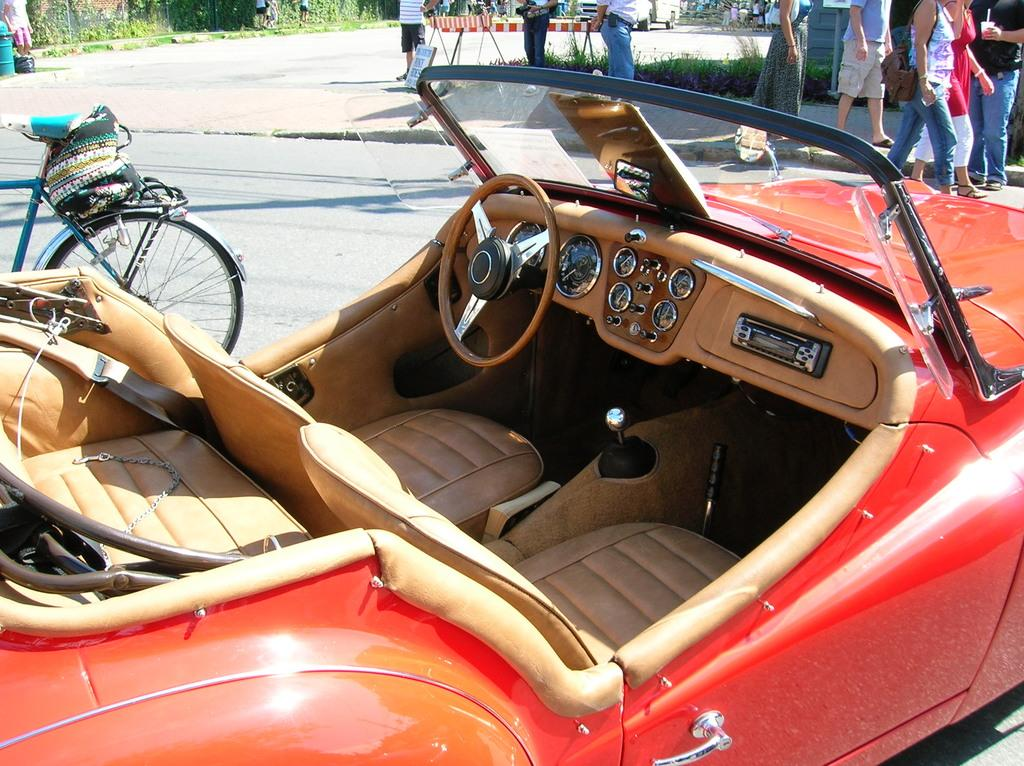What type of vehicle is in the image? There is a red color convertible car in the image. What is located behind the car? There is a bicycle behind the car. What is attached to the bicycle? The bicycle has a bag on it. Who is in the image? People are present in the image. What type of terrain is visible in the image? There is grass visible in the image. What type of stem can be seen growing from the car in the image? There is no stem growing from the car in the image; it is a convertible car without any plant-like features. 